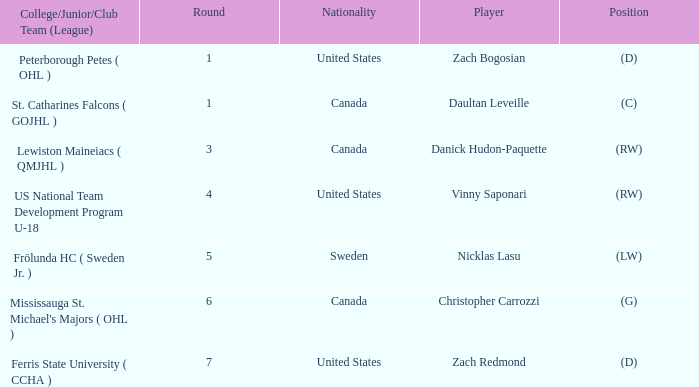What is Daultan Leveille's Position? (C). 